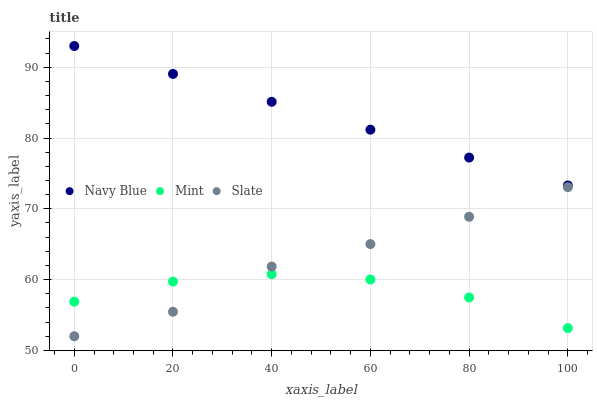Does Mint have the minimum area under the curve?
Answer yes or no. Yes. Does Navy Blue have the maximum area under the curve?
Answer yes or no. Yes. Does Slate have the minimum area under the curve?
Answer yes or no. No. Does Slate have the maximum area under the curve?
Answer yes or no. No. Is Navy Blue the smoothest?
Answer yes or no. Yes. Is Mint the roughest?
Answer yes or no. Yes. Is Slate the smoothest?
Answer yes or no. No. Is Slate the roughest?
Answer yes or no. No. Does Slate have the lowest value?
Answer yes or no. Yes. Does Mint have the lowest value?
Answer yes or no. No. Does Navy Blue have the highest value?
Answer yes or no. Yes. Does Slate have the highest value?
Answer yes or no. No. Is Mint less than Navy Blue?
Answer yes or no. Yes. Is Navy Blue greater than Slate?
Answer yes or no. Yes. Does Slate intersect Mint?
Answer yes or no. Yes. Is Slate less than Mint?
Answer yes or no. No. Is Slate greater than Mint?
Answer yes or no. No. Does Mint intersect Navy Blue?
Answer yes or no. No. 